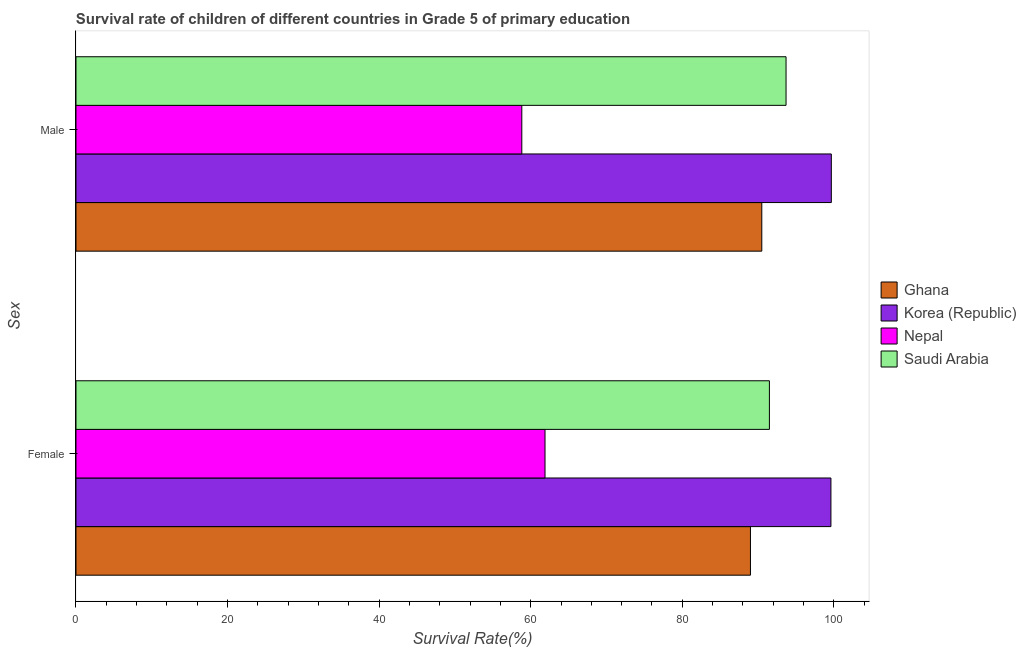How many different coloured bars are there?
Offer a very short reply. 4. Are the number of bars per tick equal to the number of legend labels?
Your response must be concise. Yes. Are the number of bars on each tick of the Y-axis equal?
Keep it short and to the point. Yes. How many bars are there on the 1st tick from the top?
Your response must be concise. 4. What is the label of the 2nd group of bars from the top?
Make the answer very short. Female. What is the survival rate of male students in primary education in Saudi Arabia?
Provide a short and direct response. 93.69. Across all countries, what is the maximum survival rate of male students in primary education?
Provide a succinct answer. 99.67. Across all countries, what is the minimum survival rate of female students in primary education?
Keep it short and to the point. 61.89. In which country was the survival rate of male students in primary education maximum?
Keep it short and to the point. Korea (Republic). In which country was the survival rate of female students in primary education minimum?
Your response must be concise. Nepal. What is the total survival rate of male students in primary education in the graph?
Give a very brief answer. 342.69. What is the difference between the survival rate of female students in primary education in Saudi Arabia and that in Ghana?
Keep it short and to the point. 2.5. What is the difference between the survival rate of male students in primary education in Ghana and the survival rate of female students in primary education in Korea (Republic)?
Ensure brevity in your answer.  -9.12. What is the average survival rate of female students in primary education per country?
Keep it short and to the point. 85.5. What is the difference between the survival rate of female students in primary education and survival rate of male students in primary education in Ghana?
Give a very brief answer. -1.5. What is the ratio of the survival rate of male students in primary education in Saudi Arabia to that in Ghana?
Offer a terse response. 1.04. Is the survival rate of male students in primary education in Nepal less than that in Ghana?
Your answer should be compact. Yes. Are all the bars in the graph horizontal?
Your response must be concise. Yes. What is the difference between two consecutive major ticks on the X-axis?
Give a very brief answer. 20. Does the graph contain grids?
Provide a succinct answer. No. How many legend labels are there?
Provide a succinct answer. 4. How are the legend labels stacked?
Offer a very short reply. Vertical. What is the title of the graph?
Offer a very short reply. Survival rate of children of different countries in Grade 5 of primary education. What is the label or title of the X-axis?
Offer a very short reply. Survival Rate(%). What is the label or title of the Y-axis?
Offer a terse response. Sex. What is the Survival Rate(%) in Ghana in Female?
Give a very brief answer. 89. What is the Survival Rate(%) of Korea (Republic) in Female?
Make the answer very short. 99.62. What is the Survival Rate(%) in Nepal in Female?
Your response must be concise. 61.89. What is the Survival Rate(%) of Saudi Arabia in Female?
Keep it short and to the point. 91.5. What is the Survival Rate(%) in Ghana in Male?
Make the answer very short. 90.49. What is the Survival Rate(%) in Korea (Republic) in Male?
Make the answer very short. 99.67. What is the Survival Rate(%) of Nepal in Male?
Provide a short and direct response. 58.83. What is the Survival Rate(%) of Saudi Arabia in Male?
Make the answer very short. 93.69. Across all Sex, what is the maximum Survival Rate(%) of Ghana?
Give a very brief answer. 90.49. Across all Sex, what is the maximum Survival Rate(%) of Korea (Republic)?
Make the answer very short. 99.67. Across all Sex, what is the maximum Survival Rate(%) in Nepal?
Give a very brief answer. 61.89. Across all Sex, what is the maximum Survival Rate(%) in Saudi Arabia?
Your answer should be compact. 93.69. Across all Sex, what is the minimum Survival Rate(%) in Ghana?
Your answer should be very brief. 89. Across all Sex, what is the minimum Survival Rate(%) of Korea (Republic)?
Offer a very short reply. 99.62. Across all Sex, what is the minimum Survival Rate(%) of Nepal?
Your answer should be very brief. 58.83. Across all Sex, what is the minimum Survival Rate(%) of Saudi Arabia?
Provide a succinct answer. 91.5. What is the total Survival Rate(%) of Ghana in the graph?
Offer a terse response. 179.49. What is the total Survival Rate(%) in Korea (Republic) in the graph?
Your response must be concise. 199.28. What is the total Survival Rate(%) of Nepal in the graph?
Ensure brevity in your answer.  120.72. What is the total Survival Rate(%) of Saudi Arabia in the graph?
Provide a short and direct response. 185.19. What is the difference between the Survival Rate(%) of Ghana in Female and that in Male?
Provide a short and direct response. -1.5. What is the difference between the Survival Rate(%) of Korea (Republic) in Female and that in Male?
Your answer should be compact. -0.05. What is the difference between the Survival Rate(%) in Nepal in Female and that in Male?
Keep it short and to the point. 3.06. What is the difference between the Survival Rate(%) in Saudi Arabia in Female and that in Male?
Your answer should be compact. -2.19. What is the difference between the Survival Rate(%) in Ghana in Female and the Survival Rate(%) in Korea (Republic) in Male?
Your response must be concise. -10.67. What is the difference between the Survival Rate(%) in Ghana in Female and the Survival Rate(%) in Nepal in Male?
Provide a short and direct response. 30.17. What is the difference between the Survival Rate(%) of Ghana in Female and the Survival Rate(%) of Saudi Arabia in Male?
Ensure brevity in your answer.  -4.7. What is the difference between the Survival Rate(%) in Korea (Republic) in Female and the Survival Rate(%) in Nepal in Male?
Offer a very short reply. 40.79. What is the difference between the Survival Rate(%) of Korea (Republic) in Female and the Survival Rate(%) of Saudi Arabia in Male?
Your response must be concise. 5.92. What is the difference between the Survival Rate(%) in Nepal in Female and the Survival Rate(%) in Saudi Arabia in Male?
Offer a terse response. -31.81. What is the average Survival Rate(%) in Ghana per Sex?
Provide a short and direct response. 89.75. What is the average Survival Rate(%) of Korea (Republic) per Sex?
Provide a short and direct response. 99.64. What is the average Survival Rate(%) of Nepal per Sex?
Provide a short and direct response. 60.36. What is the average Survival Rate(%) in Saudi Arabia per Sex?
Make the answer very short. 92.6. What is the difference between the Survival Rate(%) in Ghana and Survival Rate(%) in Korea (Republic) in Female?
Make the answer very short. -10.62. What is the difference between the Survival Rate(%) in Ghana and Survival Rate(%) in Nepal in Female?
Your answer should be compact. 27.11. What is the difference between the Survival Rate(%) in Ghana and Survival Rate(%) in Saudi Arabia in Female?
Provide a short and direct response. -2.5. What is the difference between the Survival Rate(%) in Korea (Republic) and Survival Rate(%) in Nepal in Female?
Make the answer very short. 37.73. What is the difference between the Survival Rate(%) of Korea (Republic) and Survival Rate(%) of Saudi Arabia in Female?
Your answer should be compact. 8.12. What is the difference between the Survival Rate(%) of Nepal and Survival Rate(%) of Saudi Arabia in Female?
Ensure brevity in your answer.  -29.61. What is the difference between the Survival Rate(%) in Ghana and Survival Rate(%) in Korea (Republic) in Male?
Your answer should be very brief. -9.18. What is the difference between the Survival Rate(%) in Ghana and Survival Rate(%) in Nepal in Male?
Make the answer very short. 31.67. What is the difference between the Survival Rate(%) in Ghana and Survival Rate(%) in Saudi Arabia in Male?
Give a very brief answer. -3.2. What is the difference between the Survival Rate(%) in Korea (Republic) and Survival Rate(%) in Nepal in Male?
Your answer should be very brief. 40.84. What is the difference between the Survival Rate(%) in Korea (Republic) and Survival Rate(%) in Saudi Arabia in Male?
Provide a short and direct response. 5.98. What is the difference between the Survival Rate(%) of Nepal and Survival Rate(%) of Saudi Arabia in Male?
Offer a terse response. -34.87. What is the ratio of the Survival Rate(%) in Ghana in Female to that in Male?
Your answer should be very brief. 0.98. What is the ratio of the Survival Rate(%) of Korea (Republic) in Female to that in Male?
Keep it short and to the point. 1. What is the ratio of the Survival Rate(%) in Nepal in Female to that in Male?
Your answer should be very brief. 1.05. What is the ratio of the Survival Rate(%) of Saudi Arabia in Female to that in Male?
Give a very brief answer. 0.98. What is the difference between the highest and the second highest Survival Rate(%) in Ghana?
Offer a very short reply. 1.5. What is the difference between the highest and the second highest Survival Rate(%) in Korea (Republic)?
Give a very brief answer. 0.05. What is the difference between the highest and the second highest Survival Rate(%) of Nepal?
Provide a succinct answer. 3.06. What is the difference between the highest and the second highest Survival Rate(%) of Saudi Arabia?
Provide a short and direct response. 2.19. What is the difference between the highest and the lowest Survival Rate(%) in Ghana?
Your response must be concise. 1.5. What is the difference between the highest and the lowest Survival Rate(%) in Korea (Republic)?
Offer a terse response. 0.05. What is the difference between the highest and the lowest Survival Rate(%) in Nepal?
Offer a very short reply. 3.06. What is the difference between the highest and the lowest Survival Rate(%) in Saudi Arabia?
Ensure brevity in your answer.  2.19. 